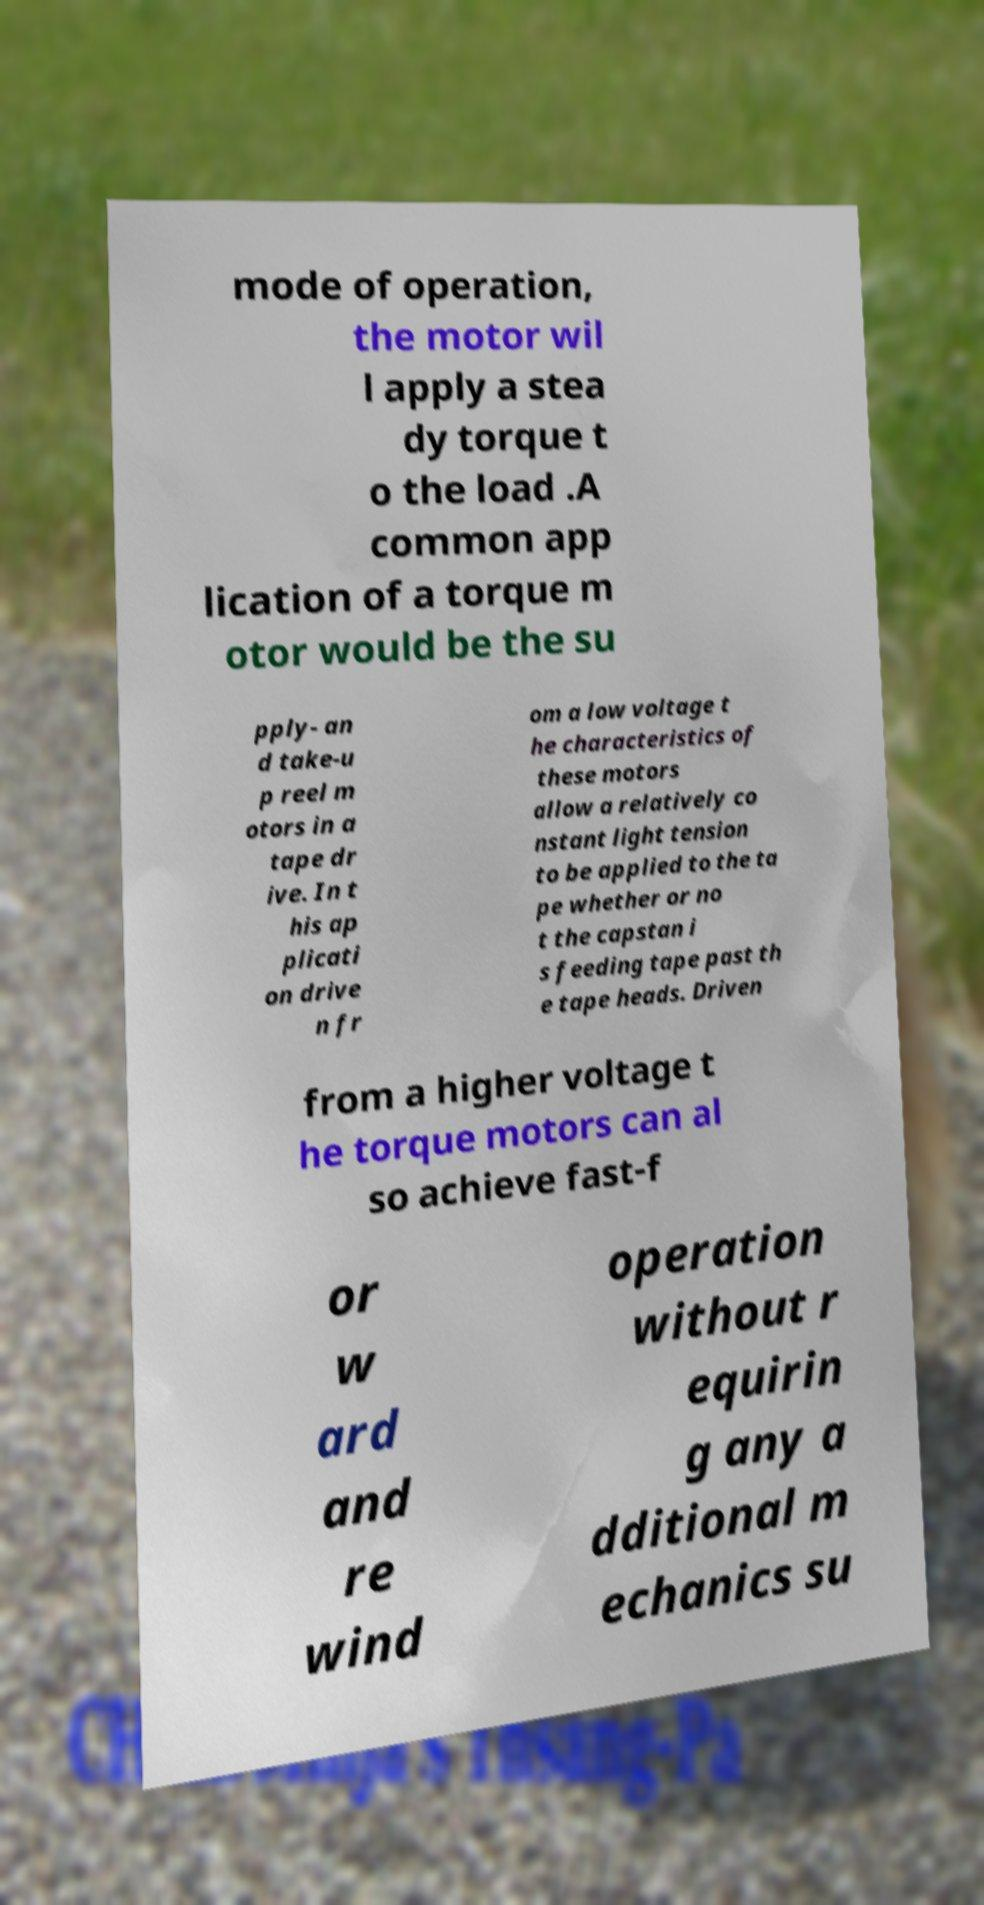For documentation purposes, I need the text within this image transcribed. Could you provide that? mode of operation, the motor wil l apply a stea dy torque t o the load .A common app lication of a torque m otor would be the su pply- an d take-u p reel m otors in a tape dr ive. In t his ap plicati on drive n fr om a low voltage t he characteristics of these motors allow a relatively co nstant light tension to be applied to the ta pe whether or no t the capstan i s feeding tape past th e tape heads. Driven from a higher voltage t he torque motors can al so achieve fast-f or w ard and re wind operation without r equirin g any a dditional m echanics su 